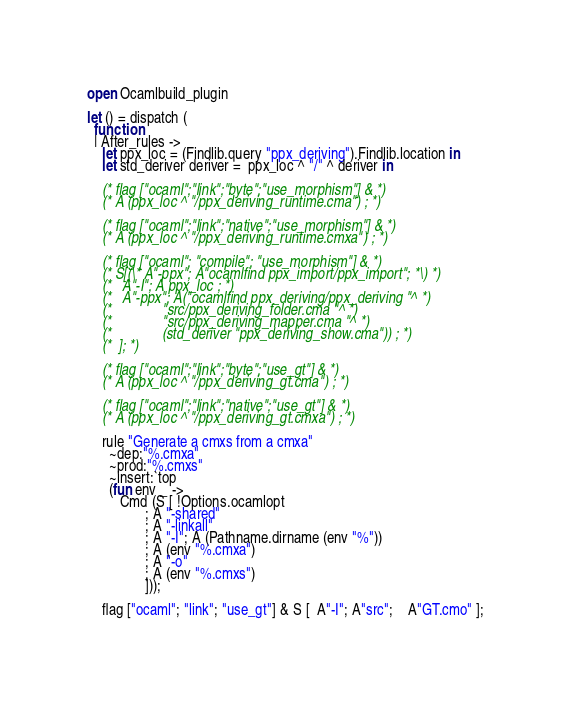Convert code to text. <code><loc_0><loc_0><loc_500><loc_500><_OCaml_>open Ocamlbuild_plugin

let () = dispatch (
  function
  | After_rules ->
    let ppx_loc = (Findlib.query "ppx_deriving").Findlib.location in
    let std_deriver deriver =  ppx_loc ^ "/" ^ deriver in

    (* flag ["ocaml";"link";"byte";"use_morphism"] & *)
    (* A (ppx_loc ^ "/ppx_deriving_runtime.cma") ; *)

    (* flag ["ocaml";"link";"native";"use_morphism"] & *)
    (* A (ppx_loc ^ "/ppx_deriving_runtime.cmxa") ; *)

    (* flag ["ocaml"; "compile"; "use_morphism"] & *)
    (* S[(\* A"-ppx"; A"ocamlfind ppx_import/ppx_import"; *\) *)
    (*   A"-I"; A ppx_loc ; *)
    (*   A"-ppx"; A("ocamlfind ppx_deriving/ppx_deriving "^ *)
    (*              "src/ppx_deriving_folder.cma "^ *)
    (*              "src/ppx_deriving_mapper.cma "^ *)
    (*              (std_deriver "ppx_deriving_show.cma")) ; *)
    (*  ]; *)

    (* flag ["ocaml";"link";"byte";"use_gt"] & *)
    (* A (ppx_loc ^ "/ppx_deriving_gt.cma") ; *)

    (* flag ["ocaml";"link";"native";"use_gt"] & *)
    (* A (ppx_loc ^ "/ppx_deriving_gt.cmxa") ; *)

    rule "Generate a cmxs from a cmxa"
      ~dep:"%.cmxa"
      ~prod:"%.cmxs"
      ~insert:`top
      (fun env _ ->
         Cmd (S [ !Options.ocamlopt
                ; A "-shared"
                ; A "-linkall"
                ; A "-I"; A (Pathname.dirname (env "%"))
                ; A (env "%.cmxa")
                ; A "-o"
                ; A (env "%.cmxs")
                ]));

    flag ["ocaml"; "link"; "use_gt"] & S [  A"-I"; A"src";    A"GT.cmo" ];</code> 